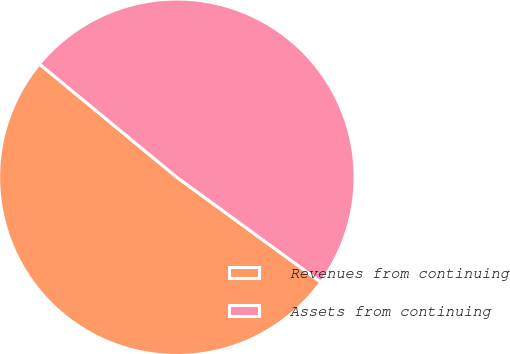Convert chart. <chart><loc_0><loc_0><loc_500><loc_500><pie_chart><fcel>Revenues from continuing<fcel>Assets from continuing<nl><fcel>50.95%<fcel>49.05%<nl></chart> 